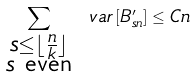Convert formula to latex. <formula><loc_0><loc_0><loc_500><loc_500>\sum _ { \substack { s \leq \lfloor \frac { n } { k } \rfloor \\ s \text { even} } } \ v a r \left [ B _ { s n } ^ { \prime } \right ] \leq C n</formula> 